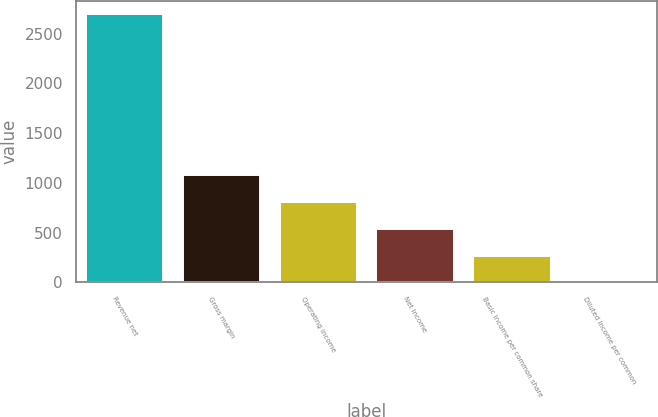Convert chart to OTSL. <chart><loc_0><loc_0><loc_500><loc_500><bar_chart><fcel>Revenue net<fcel>Gross margin<fcel>Operating income<fcel>Net income<fcel>Basic income per common share<fcel>Diluted income per common<nl><fcel>2694<fcel>1078.21<fcel>808.91<fcel>539.61<fcel>270.31<fcel>1.01<nl></chart> 